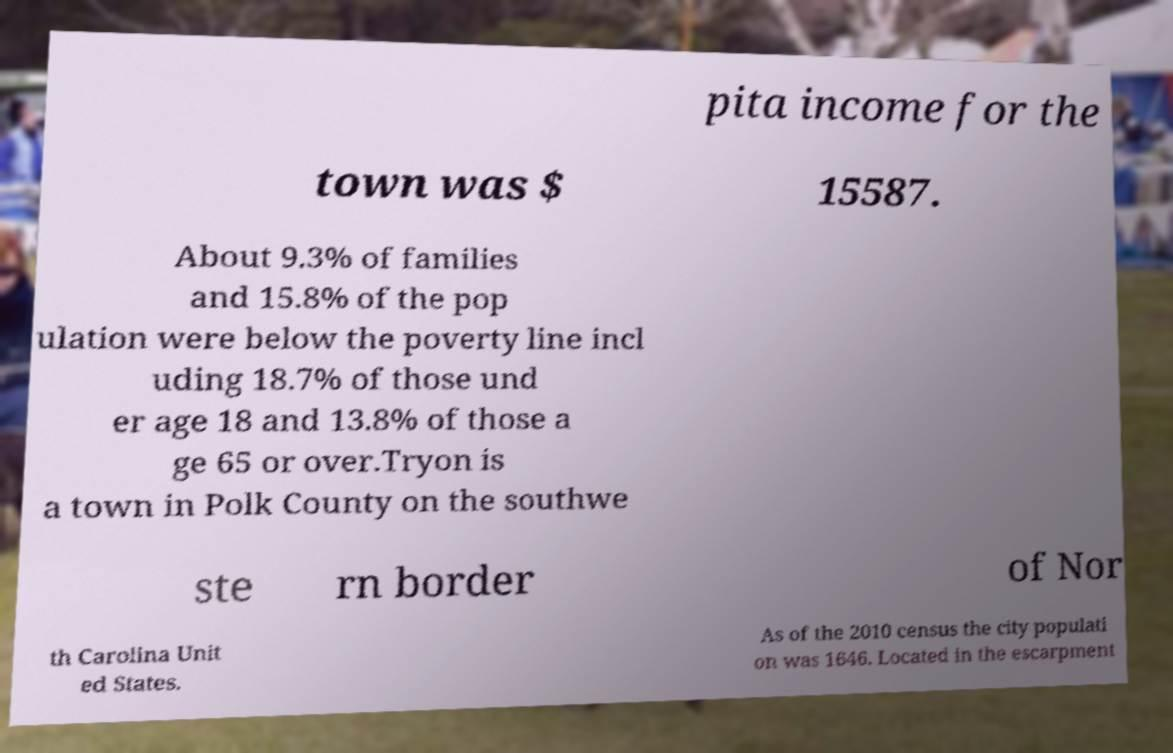Please identify and transcribe the text found in this image. pita income for the town was $ 15587. About 9.3% of families and 15.8% of the pop ulation were below the poverty line incl uding 18.7% of those und er age 18 and 13.8% of those a ge 65 or over.Tryon is a town in Polk County on the southwe ste rn border of Nor th Carolina Unit ed States. As of the 2010 census the city populati on was 1646. Located in the escarpment 